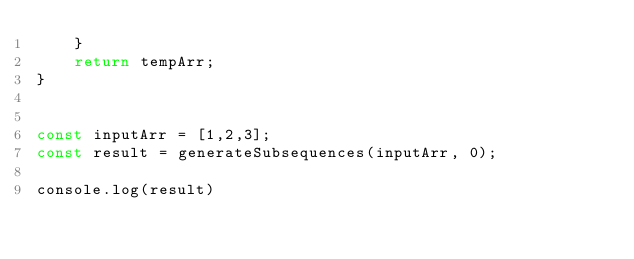<code> <loc_0><loc_0><loc_500><loc_500><_JavaScript_>    }
    return tempArr;
}


const inputArr = [1,2,3];
const result = generateSubsequences(inputArr, 0);

console.log(result)</code> 